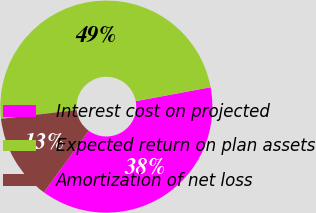Convert chart to OTSL. <chart><loc_0><loc_0><loc_500><loc_500><pie_chart><fcel>Interest cost on projected<fcel>Expected return on plan assets<fcel>Amortization of net loss<nl><fcel>37.96%<fcel>48.91%<fcel>13.14%<nl></chart> 